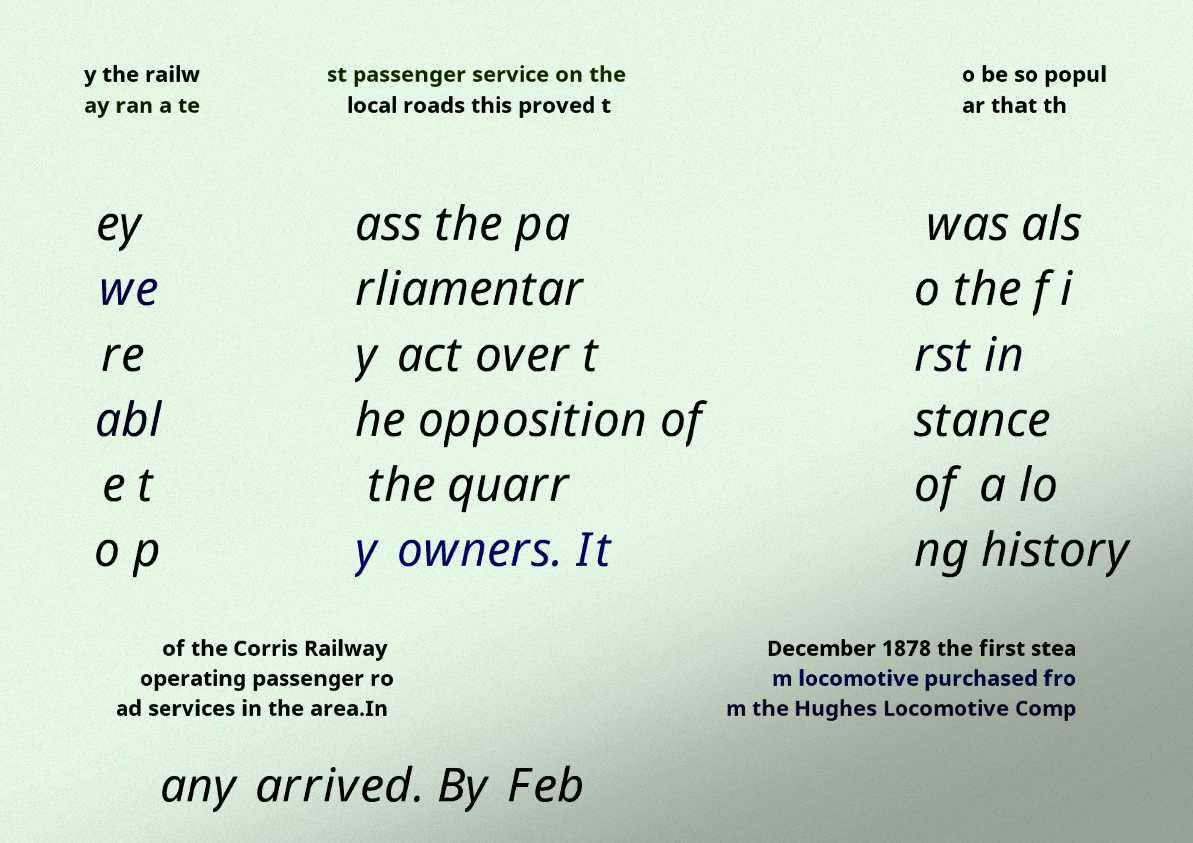I need the written content from this picture converted into text. Can you do that? y the railw ay ran a te st passenger service on the local roads this proved t o be so popul ar that th ey we re abl e t o p ass the pa rliamentar y act over t he opposition of the quarr y owners. It was als o the fi rst in stance of a lo ng history of the Corris Railway operating passenger ro ad services in the area.In December 1878 the first stea m locomotive purchased fro m the Hughes Locomotive Comp any arrived. By Feb 